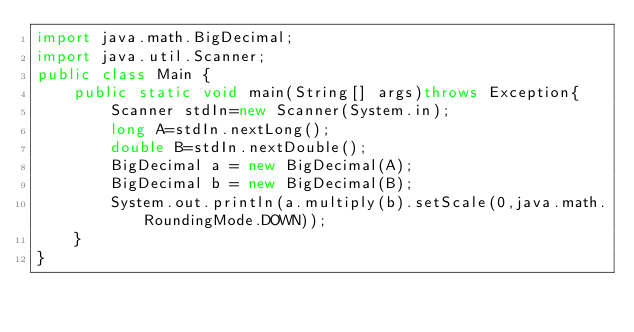Convert code to text. <code><loc_0><loc_0><loc_500><loc_500><_Java_>import java.math.BigDecimal;
import java.util.Scanner;
public class Main {
	public static void main(String[] args)throws Exception{
		Scanner stdIn=new Scanner(System.in);
		long A=stdIn.nextLong();
		double B=stdIn.nextDouble();
		BigDecimal a = new BigDecimal(A);
		BigDecimal b = new BigDecimal(B);
		System.out.println(a.multiply(b).setScale(0,java.math.RoundingMode.DOWN));
	}
}
</code> 